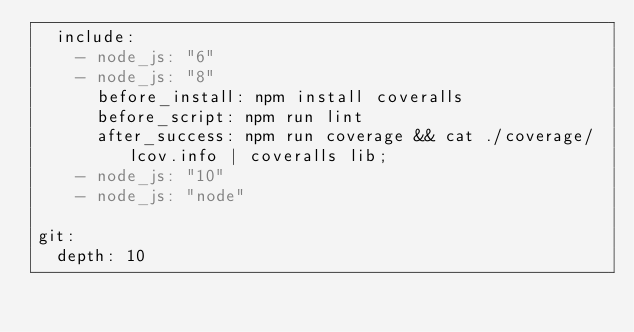<code> <loc_0><loc_0><loc_500><loc_500><_YAML_>  include:
    - node_js: "6"
    - node_js: "8"
      before_install: npm install coveralls
      before_script: npm run lint
      after_success: npm run coverage && cat ./coverage/lcov.info | coveralls lib; 
    - node_js: "10"
    - node_js: "node"    

git:
  depth: 10
</code> 